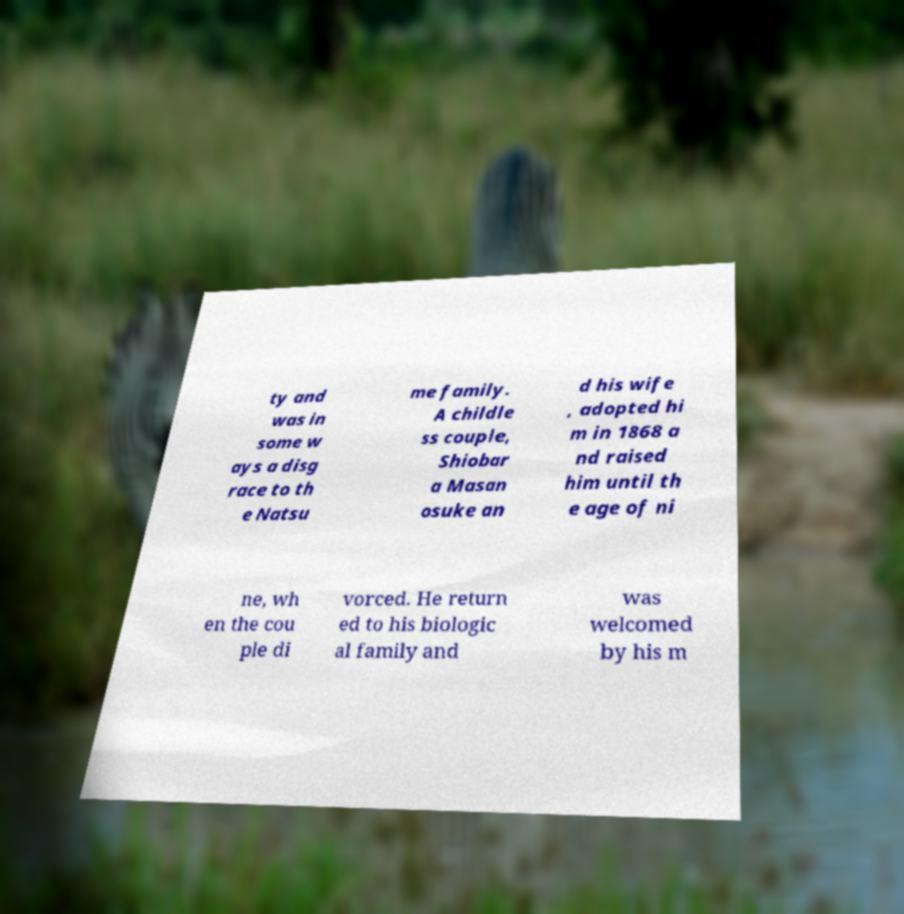Please read and relay the text visible in this image. What does it say? ty and was in some w ays a disg race to th e Natsu me family. A childle ss couple, Shiobar a Masan osuke an d his wife , adopted hi m in 1868 a nd raised him until th e age of ni ne, wh en the cou ple di vorced. He return ed to his biologic al family and was welcomed by his m 